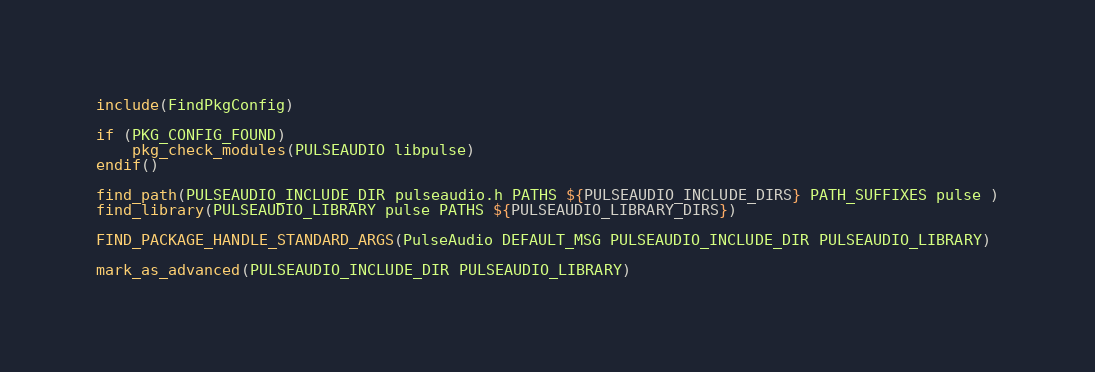<code> <loc_0><loc_0><loc_500><loc_500><_CMake_>include(FindPkgConfig)

if (PKG_CONFIG_FOUND)
	pkg_check_modules(PULSEAUDIO libpulse)
endif()

find_path(PULSEAUDIO_INCLUDE_DIR pulseaudio.h PATHS ${PULSEAUDIO_INCLUDE_DIRS} PATH_SUFFIXES pulse )
find_library(PULSEAUDIO_LIBRARY pulse PATHS ${PULSEAUDIO_LIBRARY_DIRS})

FIND_PACKAGE_HANDLE_STANDARD_ARGS(PulseAudio DEFAULT_MSG PULSEAUDIO_INCLUDE_DIR PULSEAUDIO_LIBRARY)

mark_as_advanced(PULSEAUDIO_INCLUDE_DIR PULSEAUDIO_LIBRARY)
</code> 